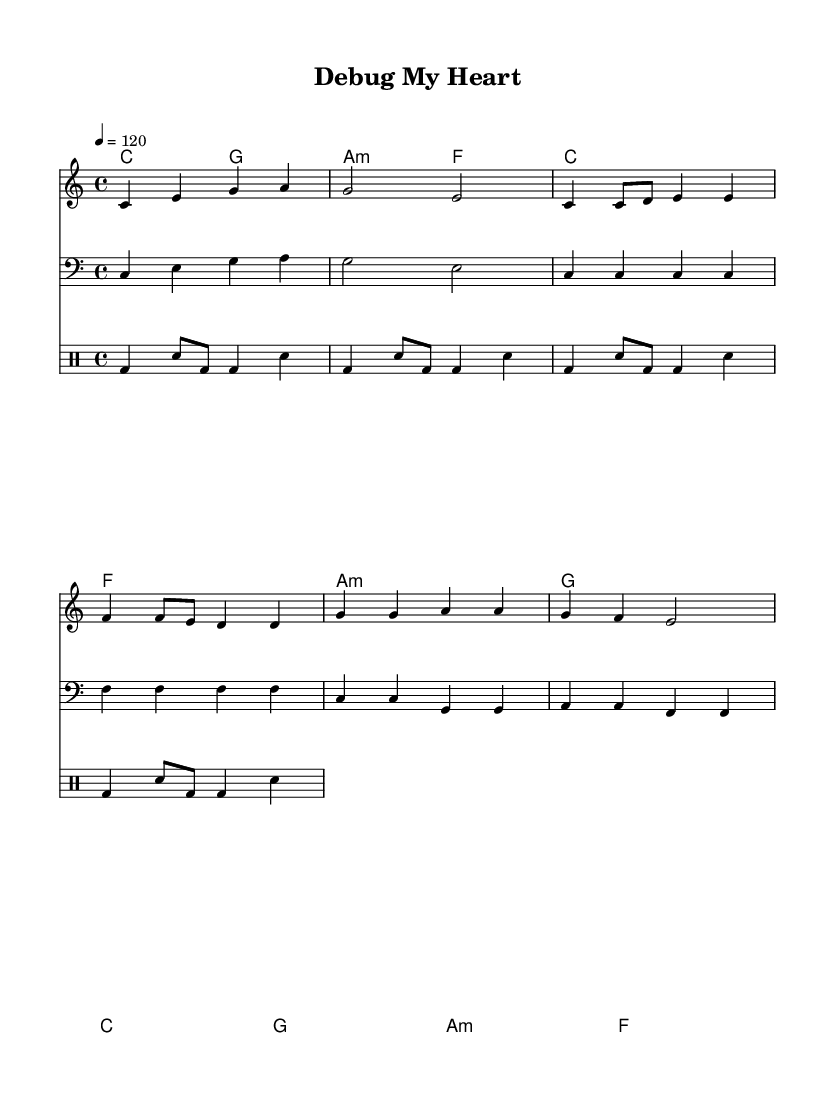What is the key signature of this music? The key signature is C major, which has no sharps or flats.
Answer: C major What is the time signature of this music? The time signature is indicated at the beginning of the score, which shows that there are four beats in a measure and the quarter note gets the beat.
Answer: 4/4 What is the tempo marking of this piece? The tempo is specified in the score as quarter note equals 120 beats per minute.
Answer: 120 What is the first chord played in the piece? The first chord indicated in the chord section is C major, which is shown in the harmony chords at the start.
Answer: C How many measures are there in the chorus section? By counting the measures in the chorus section, it can be observed that there are four measures, each containing a phrase of the lyrics.
Answer: 4 What are the lyrics of the chorus? The chorus lyrics are listed below the melody and sing "Debug my heart, find the error," thus indicating what is sung in the chorus part.
Answer: Debug my heart, find the error What is the role of the bass in this piece? The bass part plays a supportive role by following the chord progression and adding depth to the sound, which can be noted by looking at how the bass notes relate to the chords played above.
Answer: Supportive 